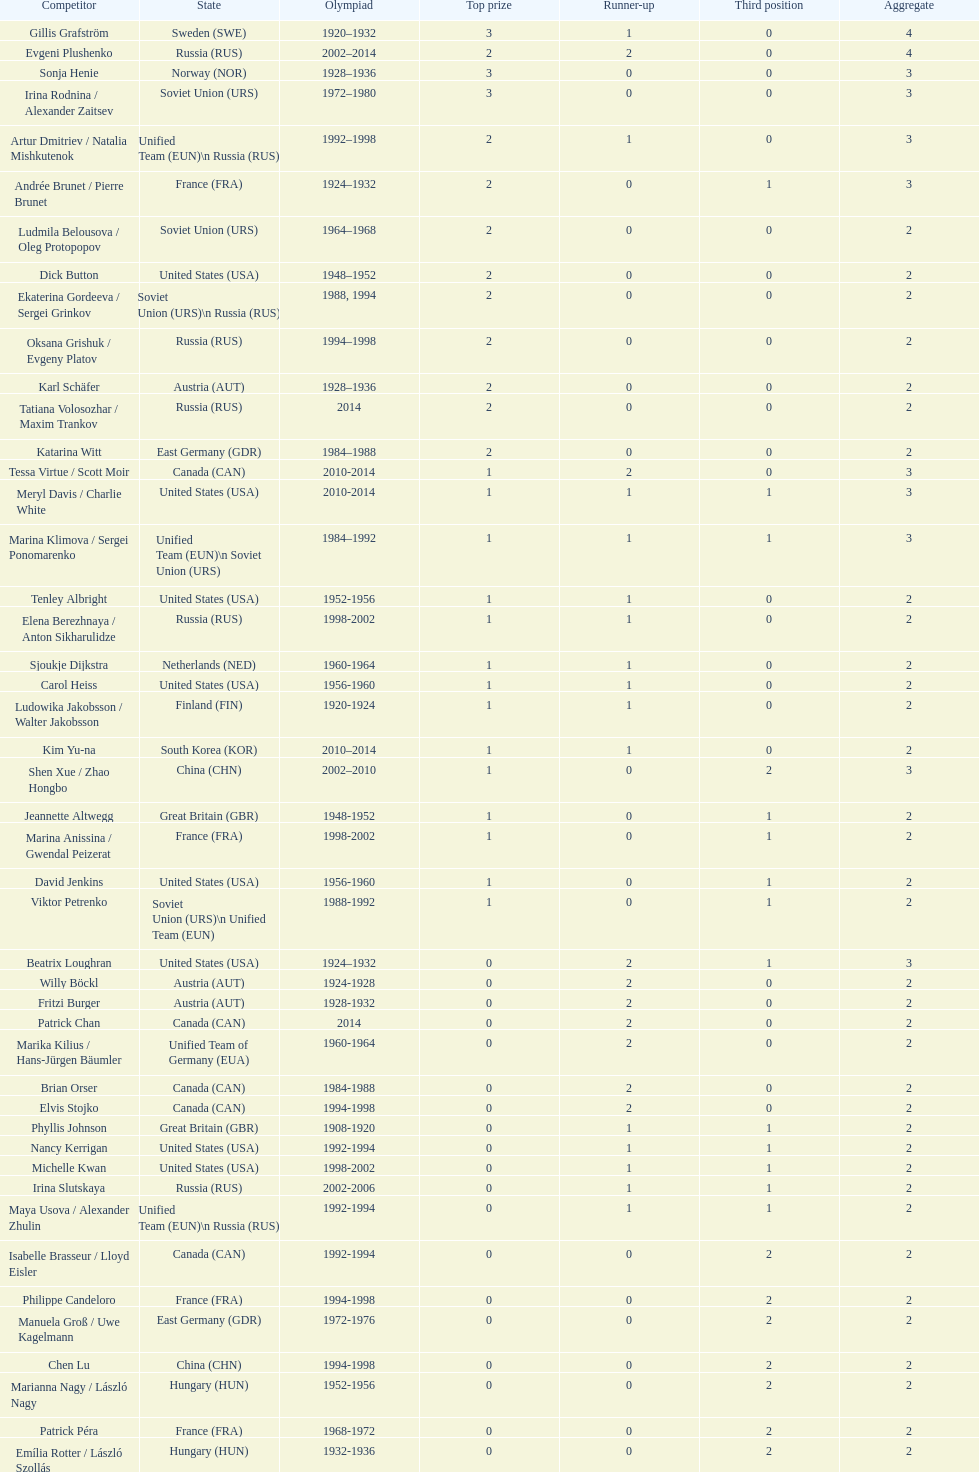Which nation was the first to win three gold medals for olympic figure skating? Sweden. 